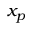Convert formula to latex. <formula><loc_0><loc_0><loc_500><loc_500>x _ { p }</formula> 